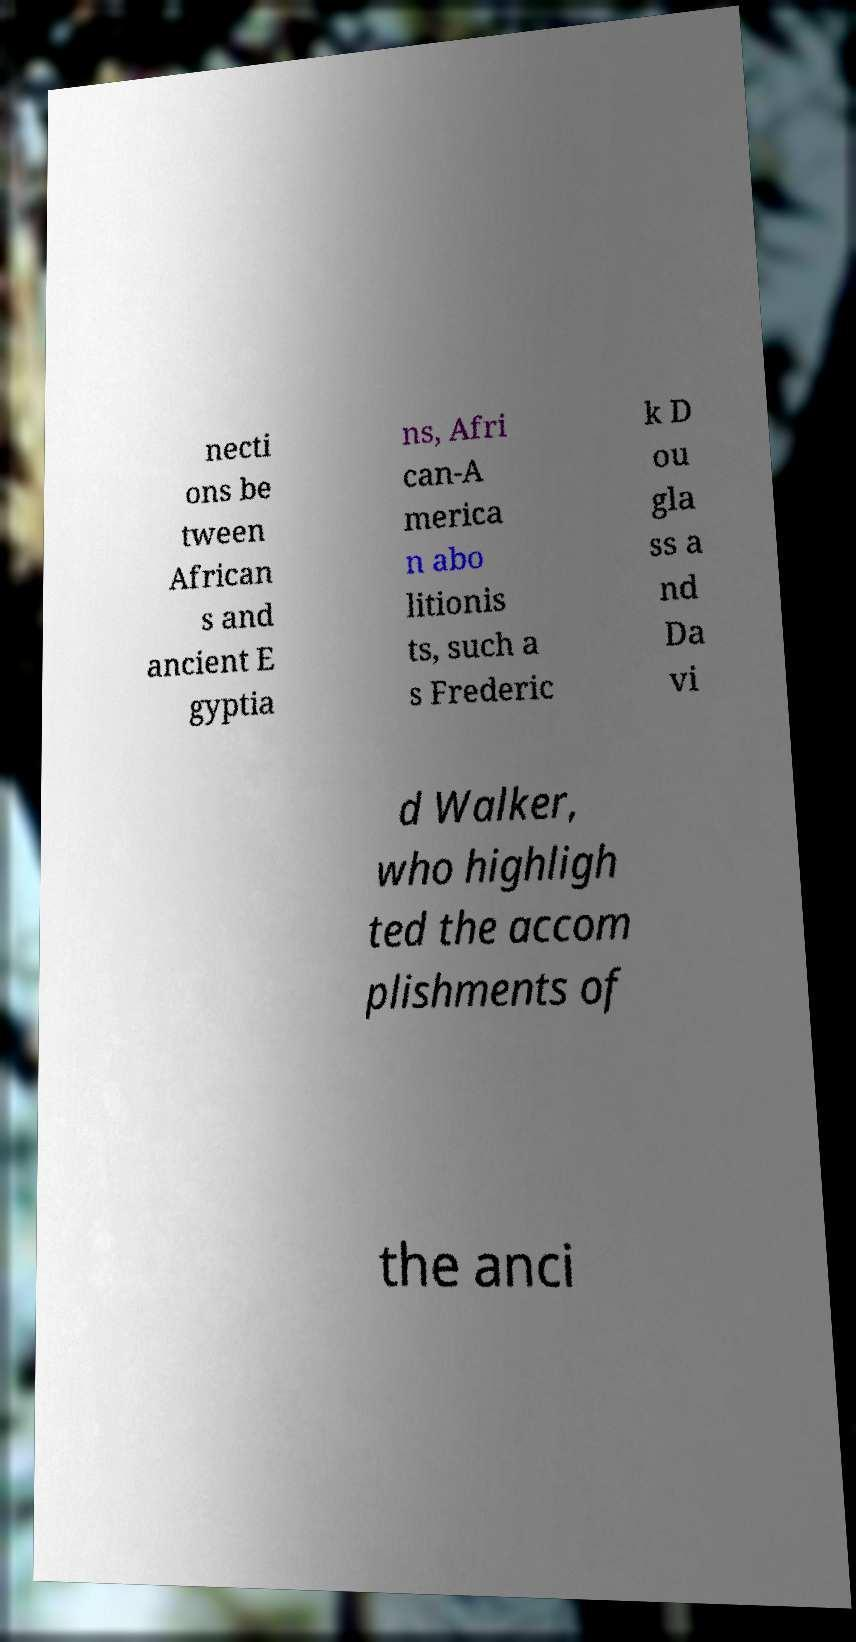Can you accurately transcribe the text from the provided image for me? necti ons be tween African s and ancient E gyptia ns, Afri can-A merica n abo litionis ts, such a s Frederic k D ou gla ss a nd Da vi d Walker, who highligh ted the accom plishments of the anci 